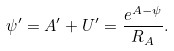<formula> <loc_0><loc_0><loc_500><loc_500>\psi ^ { \prime } = A ^ { \prime } + U ^ { \prime } = \frac { e ^ { A - \psi } } { R _ { A } } .</formula> 